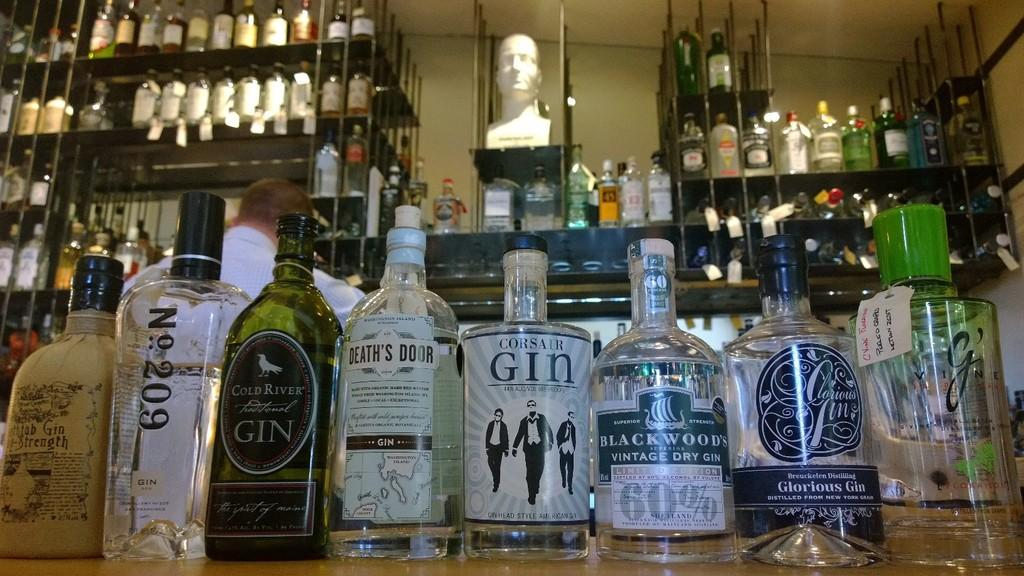<image>
Write a terse but informative summary of the picture. Bottles of gin, including one called, "Death's Door" are lined up on a bar. 